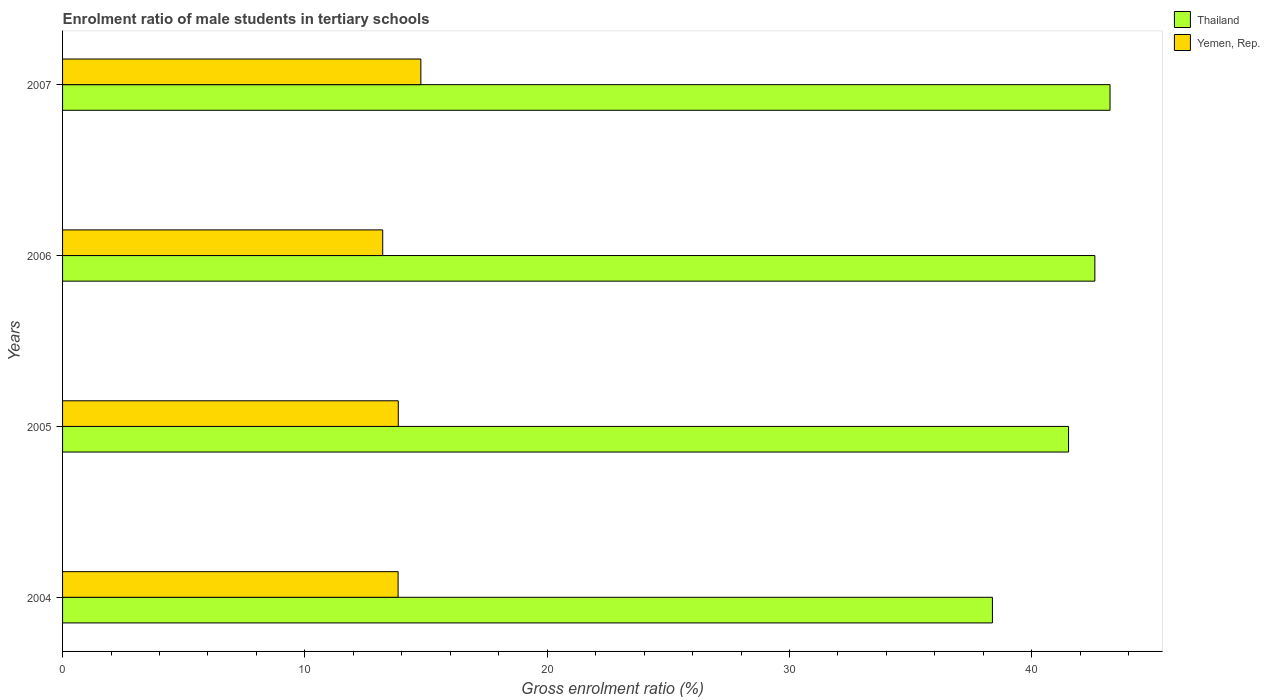Are the number of bars on each tick of the Y-axis equal?
Make the answer very short. Yes. How many bars are there on the 3rd tick from the top?
Make the answer very short. 2. How many bars are there on the 2nd tick from the bottom?
Your answer should be very brief. 2. What is the label of the 1st group of bars from the top?
Offer a very short reply. 2007. In how many cases, is the number of bars for a given year not equal to the number of legend labels?
Offer a very short reply. 0. What is the enrolment ratio of male students in tertiary schools in Thailand in 2005?
Your answer should be compact. 41.52. Across all years, what is the maximum enrolment ratio of male students in tertiary schools in Yemen, Rep.?
Keep it short and to the point. 14.79. Across all years, what is the minimum enrolment ratio of male students in tertiary schools in Yemen, Rep.?
Provide a short and direct response. 13.21. In which year was the enrolment ratio of male students in tertiary schools in Thailand maximum?
Give a very brief answer. 2007. What is the total enrolment ratio of male students in tertiary schools in Yemen, Rep. in the graph?
Offer a terse response. 55.7. What is the difference between the enrolment ratio of male students in tertiary schools in Yemen, Rep. in 2004 and that in 2007?
Make the answer very short. -0.94. What is the difference between the enrolment ratio of male students in tertiary schools in Yemen, Rep. in 2005 and the enrolment ratio of male students in tertiary schools in Thailand in 2007?
Your answer should be very brief. -29.37. What is the average enrolment ratio of male students in tertiary schools in Yemen, Rep. per year?
Offer a terse response. 13.93. In the year 2006, what is the difference between the enrolment ratio of male students in tertiary schools in Yemen, Rep. and enrolment ratio of male students in tertiary schools in Thailand?
Keep it short and to the point. -29.39. In how many years, is the enrolment ratio of male students in tertiary schools in Yemen, Rep. greater than 40 %?
Give a very brief answer. 0. What is the ratio of the enrolment ratio of male students in tertiary schools in Yemen, Rep. in 2006 to that in 2007?
Make the answer very short. 0.89. Is the difference between the enrolment ratio of male students in tertiary schools in Yemen, Rep. in 2004 and 2006 greater than the difference between the enrolment ratio of male students in tertiary schools in Thailand in 2004 and 2006?
Provide a succinct answer. Yes. What is the difference between the highest and the second highest enrolment ratio of male students in tertiary schools in Yemen, Rep.?
Your answer should be very brief. 0.93. What is the difference between the highest and the lowest enrolment ratio of male students in tertiary schools in Yemen, Rep.?
Make the answer very short. 1.57. What does the 2nd bar from the top in 2005 represents?
Provide a succinct answer. Thailand. What does the 1st bar from the bottom in 2006 represents?
Make the answer very short. Thailand. Are all the bars in the graph horizontal?
Provide a short and direct response. Yes. How many years are there in the graph?
Make the answer very short. 4. What is the difference between two consecutive major ticks on the X-axis?
Ensure brevity in your answer.  10. Does the graph contain grids?
Offer a very short reply. No. Where does the legend appear in the graph?
Your answer should be compact. Top right. How are the legend labels stacked?
Your answer should be very brief. Vertical. What is the title of the graph?
Your response must be concise. Enrolment ratio of male students in tertiary schools. What is the label or title of the X-axis?
Keep it short and to the point. Gross enrolment ratio (%). What is the Gross enrolment ratio (%) in Thailand in 2004?
Keep it short and to the point. 38.37. What is the Gross enrolment ratio (%) in Yemen, Rep. in 2004?
Provide a succinct answer. 13.85. What is the Gross enrolment ratio (%) in Thailand in 2005?
Make the answer very short. 41.52. What is the Gross enrolment ratio (%) of Yemen, Rep. in 2005?
Give a very brief answer. 13.85. What is the Gross enrolment ratio (%) of Thailand in 2006?
Give a very brief answer. 42.6. What is the Gross enrolment ratio (%) of Yemen, Rep. in 2006?
Ensure brevity in your answer.  13.21. What is the Gross enrolment ratio (%) of Thailand in 2007?
Your answer should be compact. 43.23. What is the Gross enrolment ratio (%) in Yemen, Rep. in 2007?
Ensure brevity in your answer.  14.79. Across all years, what is the maximum Gross enrolment ratio (%) of Thailand?
Ensure brevity in your answer.  43.23. Across all years, what is the maximum Gross enrolment ratio (%) in Yemen, Rep.?
Your response must be concise. 14.79. Across all years, what is the minimum Gross enrolment ratio (%) of Thailand?
Offer a terse response. 38.37. Across all years, what is the minimum Gross enrolment ratio (%) of Yemen, Rep.?
Your answer should be compact. 13.21. What is the total Gross enrolment ratio (%) in Thailand in the graph?
Give a very brief answer. 165.72. What is the total Gross enrolment ratio (%) in Yemen, Rep. in the graph?
Keep it short and to the point. 55.7. What is the difference between the Gross enrolment ratio (%) in Thailand in 2004 and that in 2005?
Your response must be concise. -3.14. What is the difference between the Gross enrolment ratio (%) of Yemen, Rep. in 2004 and that in 2005?
Your response must be concise. -0.01. What is the difference between the Gross enrolment ratio (%) of Thailand in 2004 and that in 2006?
Provide a short and direct response. -4.23. What is the difference between the Gross enrolment ratio (%) in Yemen, Rep. in 2004 and that in 2006?
Keep it short and to the point. 0.64. What is the difference between the Gross enrolment ratio (%) of Thailand in 2004 and that in 2007?
Provide a succinct answer. -4.85. What is the difference between the Gross enrolment ratio (%) of Yemen, Rep. in 2004 and that in 2007?
Offer a terse response. -0.94. What is the difference between the Gross enrolment ratio (%) in Thailand in 2005 and that in 2006?
Offer a terse response. -1.08. What is the difference between the Gross enrolment ratio (%) in Yemen, Rep. in 2005 and that in 2006?
Give a very brief answer. 0.64. What is the difference between the Gross enrolment ratio (%) of Thailand in 2005 and that in 2007?
Provide a short and direct response. -1.71. What is the difference between the Gross enrolment ratio (%) of Yemen, Rep. in 2005 and that in 2007?
Keep it short and to the point. -0.93. What is the difference between the Gross enrolment ratio (%) of Thailand in 2006 and that in 2007?
Offer a terse response. -0.63. What is the difference between the Gross enrolment ratio (%) in Yemen, Rep. in 2006 and that in 2007?
Offer a very short reply. -1.57. What is the difference between the Gross enrolment ratio (%) of Thailand in 2004 and the Gross enrolment ratio (%) of Yemen, Rep. in 2005?
Your answer should be compact. 24.52. What is the difference between the Gross enrolment ratio (%) in Thailand in 2004 and the Gross enrolment ratio (%) in Yemen, Rep. in 2006?
Your answer should be compact. 25.16. What is the difference between the Gross enrolment ratio (%) in Thailand in 2004 and the Gross enrolment ratio (%) in Yemen, Rep. in 2007?
Provide a short and direct response. 23.59. What is the difference between the Gross enrolment ratio (%) of Thailand in 2005 and the Gross enrolment ratio (%) of Yemen, Rep. in 2006?
Your answer should be very brief. 28.3. What is the difference between the Gross enrolment ratio (%) of Thailand in 2005 and the Gross enrolment ratio (%) of Yemen, Rep. in 2007?
Give a very brief answer. 26.73. What is the difference between the Gross enrolment ratio (%) in Thailand in 2006 and the Gross enrolment ratio (%) in Yemen, Rep. in 2007?
Provide a succinct answer. 27.82. What is the average Gross enrolment ratio (%) of Thailand per year?
Provide a short and direct response. 41.43. What is the average Gross enrolment ratio (%) in Yemen, Rep. per year?
Offer a terse response. 13.93. In the year 2004, what is the difference between the Gross enrolment ratio (%) in Thailand and Gross enrolment ratio (%) in Yemen, Rep.?
Offer a terse response. 24.53. In the year 2005, what is the difference between the Gross enrolment ratio (%) of Thailand and Gross enrolment ratio (%) of Yemen, Rep.?
Provide a succinct answer. 27.66. In the year 2006, what is the difference between the Gross enrolment ratio (%) of Thailand and Gross enrolment ratio (%) of Yemen, Rep.?
Offer a very short reply. 29.39. In the year 2007, what is the difference between the Gross enrolment ratio (%) of Thailand and Gross enrolment ratio (%) of Yemen, Rep.?
Ensure brevity in your answer.  28.44. What is the ratio of the Gross enrolment ratio (%) of Thailand in 2004 to that in 2005?
Provide a succinct answer. 0.92. What is the ratio of the Gross enrolment ratio (%) of Thailand in 2004 to that in 2006?
Make the answer very short. 0.9. What is the ratio of the Gross enrolment ratio (%) in Yemen, Rep. in 2004 to that in 2006?
Make the answer very short. 1.05. What is the ratio of the Gross enrolment ratio (%) of Thailand in 2004 to that in 2007?
Keep it short and to the point. 0.89. What is the ratio of the Gross enrolment ratio (%) of Yemen, Rep. in 2004 to that in 2007?
Give a very brief answer. 0.94. What is the ratio of the Gross enrolment ratio (%) in Thailand in 2005 to that in 2006?
Offer a terse response. 0.97. What is the ratio of the Gross enrolment ratio (%) of Yemen, Rep. in 2005 to that in 2006?
Provide a succinct answer. 1.05. What is the ratio of the Gross enrolment ratio (%) of Thailand in 2005 to that in 2007?
Your answer should be very brief. 0.96. What is the ratio of the Gross enrolment ratio (%) in Yemen, Rep. in 2005 to that in 2007?
Give a very brief answer. 0.94. What is the ratio of the Gross enrolment ratio (%) in Thailand in 2006 to that in 2007?
Keep it short and to the point. 0.99. What is the ratio of the Gross enrolment ratio (%) of Yemen, Rep. in 2006 to that in 2007?
Ensure brevity in your answer.  0.89. What is the difference between the highest and the second highest Gross enrolment ratio (%) in Thailand?
Your response must be concise. 0.63. What is the difference between the highest and the second highest Gross enrolment ratio (%) of Yemen, Rep.?
Ensure brevity in your answer.  0.93. What is the difference between the highest and the lowest Gross enrolment ratio (%) in Thailand?
Keep it short and to the point. 4.85. What is the difference between the highest and the lowest Gross enrolment ratio (%) in Yemen, Rep.?
Ensure brevity in your answer.  1.57. 